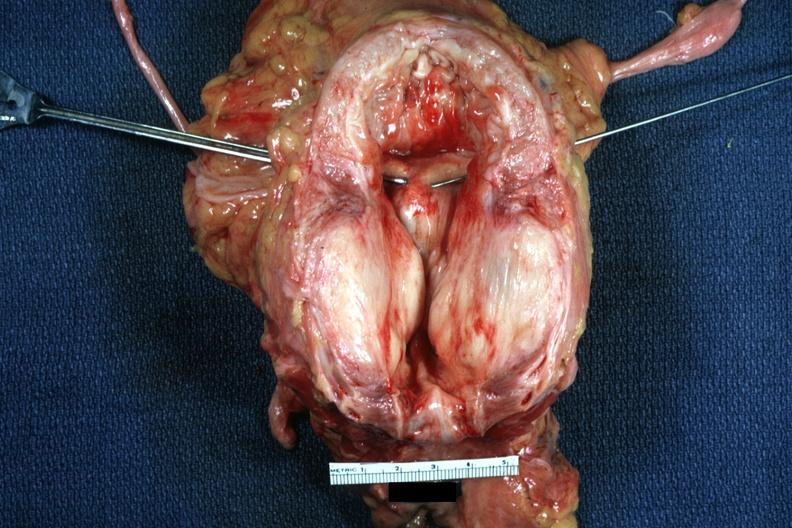what does this image show?
Answer the question using a single word or phrase. Excellent very large gland hypertrophied bladder 